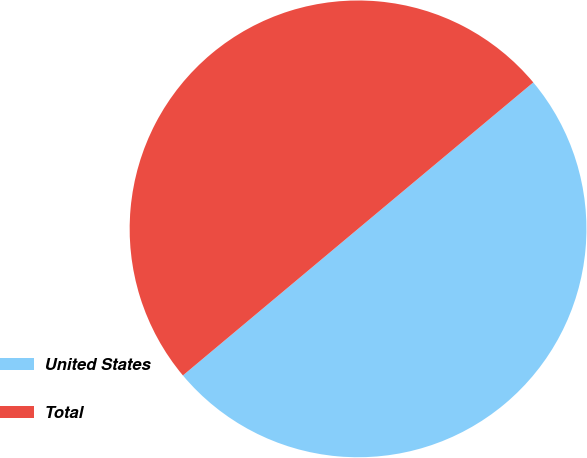Convert chart. <chart><loc_0><loc_0><loc_500><loc_500><pie_chart><fcel>United States<fcel>Total<nl><fcel>49.99%<fcel>50.01%<nl></chart> 